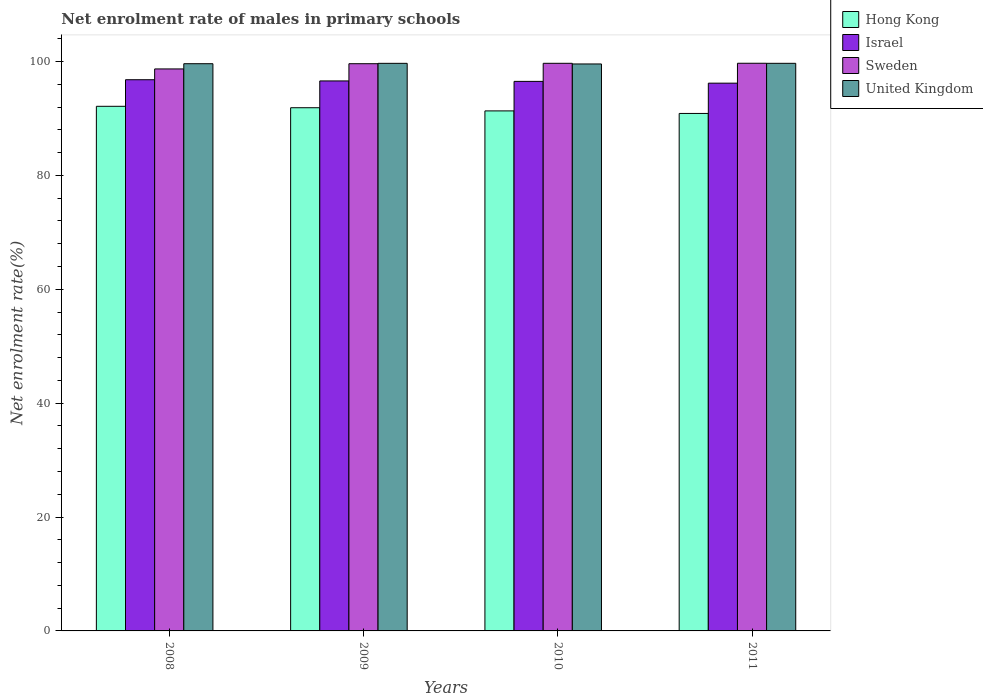Are the number of bars on each tick of the X-axis equal?
Your response must be concise. Yes. How many bars are there on the 1st tick from the left?
Provide a short and direct response. 4. How many bars are there on the 3rd tick from the right?
Provide a short and direct response. 4. In how many cases, is the number of bars for a given year not equal to the number of legend labels?
Ensure brevity in your answer.  0. What is the net enrolment rate of males in primary schools in Hong Kong in 2008?
Give a very brief answer. 92.14. Across all years, what is the maximum net enrolment rate of males in primary schools in Israel?
Offer a very short reply. 96.81. Across all years, what is the minimum net enrolment rate of males in primary schools in Sweden?
Give a very brief answer. 98.71. In which year was the net enrolment rate of males in primary schools in United Kingdom minimum?
Keep it short and to the point. 2010. What is the total net enrolment rate of males in primary schools in Hong Kong in the graph?
Ensure brevity in your answer.  366.26. What is the difference between the net enrolment rate of males in primary schools in Sweden in 2009 and that in 2010?
Ensure brevity in your answer.  -0.07. What is the difference between the net enrolment rate of males in primary schools in United Kingdom in 2011 and the net enrolment rate of males in primary schools in Sweden in 2009?
Offer a terse response. 0.07. What is the average net enrolment rate of males in primary schools in Hong Kong per year?
Your answer should be very brief. 91.57. In the year 2008, what is the difference between the net enrolment rate of males in primary schools in Hong Kong and net enrolment rate of males in primary schools in United Kingdom?
Ensure brevity in your answer.  -7.48. In how many years, is the net enrolment rate of males in primary schools in United Kingdom greater than 52 %?
Provide a succinct answer. 4. What is the ratio of the net enrolment rate of males in primary schools in Sweden in 2010 to that in 2011?
Offer a terse response. 1. What is the difference between the highest and the second highest net enrolment rate of males in primary schools in United Kingdom?
Give a very brief answer. 0. What is the difference between the highest and the lowest net enrolment rate of males in primary schools in Hong Kong?
Your response must be concise. 1.25. In how many years, is the net enrolment rate of males in primary schools in United Kingdom greater than the average net enrolment rate of males in primary schools in United Kingdom taken over all years?
Your response must be concise. 2. What does the 4th bar from the right in 2009 represents?
Your answer should be very brief. Hong Kong. How many bars are there?
Give a very brief answer. 16. What is the difference between two consecutive major ticks on the Y-axis?
Give a very brief answer. 20. Does the graph contain any zero values?
Your response must be concise. No. Where does the legend appear in the graph?
Your answer should be compact. Top right. How many legend labels are there?
Offer a terse response. 4. What is the title of the graph?
Give a very brief answer. Net enrolment rate of males in primary schools. Does "Europe(developing only)" appear as one of the legend labels in the graph?
Offer a very short reply. No. What is the label or title of the X-axis?
Your answer should be very brief. Years. What is the label or title of the Y-axis?
Your response must be concise. Net enrolment rate(%). What is the Net enrolment rate(%) in Hong Kong in 2008?
Provide a short and direct response. 92.14. What is the Net enrolment rate(%) in Israel in 2008?
Your answer should be very brief. 96.81. What is the Net enrolment rate(%) of Sweden in 2008?
Offer a very short reply. 98.71. What is the Net enrolment rate(%) in United Kingdom in 2008?
Provide a short and direct response. 99.63. What is the Net enrolment rate(%) of Hong Kong in 2009?
Offer a very short reply. 91.89. What is the Net enrolment rate(%) in Israel in 2009?
Your answer should be compact. 96.6. What is the Net enrolment rate(%) in Sweden in 2009?
Ensure brevity in your answer.  99.63. What is the Net enrolment rate(%) in United Kingdom in 2009?
Offer a terse response. 99.69. What is the Net enrolment rate(%) of Hong Kong in 2010?
Your response must be concise. 91.34. What is the Net enrolment rate(%) in Israel in 2010?
Provide a short and direct response. 96.52. What is the Net enrolment rate(%) in Sweden in 2010?
Your answer should be compact. 99.7. What is the Net enrolment rate(%) in United Kingdom in 2010?
Give a very brief answer. 99.58. What is the Net enrolment rate(%) of Hong Kong in 2011?
Offer a terse response. 90.89. What is the Net enrolment rate(%) of Israel in 2011?
Offer a terse response. 96.21. What is the Net enrolment rate(%) of Sweden in 2011?
Provide a short and direct response. 99.7. What is the Net enrolment rate(%) in United Kingdom in 2011?
Give a very brief answer. 99.69. Across all years, what is the maximum Net enrolment rate(%) of Hong Kong?
Provide a succinct answer. 92.14. Across all years, what is the maximum Net enrolment rate(%) in Israel?
Provide a succinct answer. 96.81. Across all years, what is the maximum Net enrolment rate(%) in Sweden?
Offer a very short reply. 99.7. Across all years, what is the maximum Net enrolment rate(%) of United Kingdom?
Your response must be concise. 99.69. Across all years, what is the minimum Net enrolment rate(%) in Hong Kong?
Give a very brief answer. 90.89. Across all years, what is the minimum Net enrolment rate(%) in Israel?
Provide a succinct answer. 96.21. Across all years, what is the minimum Net enrolment rate(%) of Sweden?
Provide a succinct answer. 98.71. Across all years, what is the minimum Net enrolment rate(%) in United Kingdom?
Ensure brevity in your answer.  99.58. What is the total Net enrolment rate(%) of Hong Kong in the graph?
Ensure brevity in your answer.  366.26. What is the total Net enrolment rate(%) of Israel in the graph?
Provide a short and direct response. 386.14. What is the total Net enrolment rate(%) in Sweden in the graph?
Give a very brief answer. 397.73. What is the total Net enrolment rate(%) in United Kingdom in the graph?
Offer a terse response. 398.59. What is the difference between the Net enrolment rate(%) in Hong Kong in 2008 and that in 2009?
Your answer should be compact. 0.25. What is the difference between the Net enrolment rate(%) in Israel in 2008 and that in 2009?
Your answer should be very brief. 0.21. What is the difference between the Net enrolment rate(%) of Sweden in 2008 and that in 2009?
Your answer should be compact. -0.92. What is the difference between the Net enrolment rate(%) in United Kingdom in 2008 and that in 2009?
Provide a short and direct response. -0.06. What is the difference between the Net enrolment rate(%) in Hong Kong in 2008 and that in 2010?
Offer a very short reply. 0.81. What is the difference between the Net enrolment rate(%) in Israel in 2008 and that in 2010?
Give a very brief answer. 0.29. What is the difference between the Net enrolment rate(%) of Sweden in 2008 and that in 2010?
Offer a terse response. -0.99. What is the difference between the Net enrolment rate(%) of United Kingdom in 2008 and that in 2010?
Keep it short and to the point. 0.04. What is the difference between the Net enrolment rate(%) of Hong Kong in 2008 and that in 2011?
Provide a succinct answer. 1.25. What is the difference between the Net enrolment rate(%) in Israel in 2008 and that in 2011?
Provide a succinct answer. 0.6. What is the difference between the Net enrolment rate(%) of Sweden in 2008 and that in 2011?
Your answer should be very brief. -1. What is the difference between the Net enrolment rate(%) of United Kingdom in 2008 and that in 2011?
Provide a succinct answer. -0.07. What is the difference between the Net enrolment rate(%) in Hong Kong in 2009 and that in 2010?
Your answer should be compact. 0.56. What is the difference between the Net enrolment rate(%) of Israel in 2009 and that in 2010?
Your response must be concise. 0.08. What is the difference between the Net enrolment rate(%) in Sweden in 2009 and that in 2010?
Ensure brevity in your answer.  -0.07. What is the difference between the Net enrolment rate(%) of United Kingdom in 2009 and that in 2010?
Make the answer very short. 0.11. What is the difference between the Net enrolment rate(%) in Hong Kong in 2009 and that in 2011?
Offer a terse response. 1. What is the difference between the Net enrolment rate(%) of Israel in 2009 and that in 2011?
Provide a short and direct response. 0.39. What is the difference between the Net enrolment rate(%) of Sweden in 2009 and that in 2011?
Keep it short and to the point. -0.08. What is the difference between the Net enrolment rate(%) in United Kingdom in 2009 and that in 2011?
Ensure brevity in your answer.  -0. What is the difference between the Net enrolment rate(%) in Hong Kong in 2010 and that in 2011?
Provide a succinct answer. 0.45. What is the difference between the Net enrolment rate(%) in Israel in 2010 and that in 2011?
Your answer should be very brief. 0.31. What is the difference between the Net enrolment rate(%) in Sweden in 2010 and that in 2011?
Your answer should be very brief. -0.01. What is the difference between the Net enrolment rate(%) of United Kingdom in 2010 and that in 2011?
Provide a short and direct response. -0.11. What is the difference between the Net enrolment rate(%) of Hong Kong in 2008 and the Net enrolment rate(%) of Israel in 2009?
Keep it short and to the point. -4.46. What is the difference between the Net enrolment rate(%) of Hong Kong in 2008 and the Net enrolment rate(%) of Sweden in 2009?
Your answer should be very brief. -7.48. What is the difference between the Net enrolment rate(%) in Hong Kong in 2008 and the Net enrolment rate(%) in United Kingdom in 2009?
Your response must be concise. -7.55. What is the difference between the Net enrolment rate(%) of Israel in 2008 and the Net enrolment rate(%) of Sweden in 2009?
Offer a very short reply. -2.81. What is the difference between the Net enrolment rate(%) in Israel in 2008 and the Net enrolment rate(%) in United Kingdom in 2009?
Make the answer very short. -2.88. What is the difference between the Net enrolment rate(%) in Sweden in 2008 and the Net enrolment rate(%) in United Kingdom in 2009?
Your answer should be compact. -0.98. What is the difference between the Net enrolment rate(%) in Hong Kong in 2008 and the Net enrolment rate(%) in Israel in 2010?
Give a very brief answer. -4.38. What is the difference between the Net enrolment rate(%) in Hong Kong in 2008 and the Net enrolment rate(%) in Sweden in 2010?
Your answer should be compact. -7.55. What is the difference between the Net enrolment rate(%) of Hong Kong in 2008 and the Net enrolment rate(%) of United Kingdom in 2010?
Your answer should be very brief. -7.44. What is the difference between the Net enrolment rate(%) in Israel in 2008 and the Net enrolment rate(%) in Sweden in 2010?
Your answer should be very brief. -2.89. What is the difference between the Net enrolment rate(%) of Israel in 2008 and the Net enrolment rate(%) of United Kingdom in 2010?
Provide a short and direct response. -2.77. What is the difference between the Net enrolment rate(%) of Sweden in 2008 and the Net enrolment rate(%) of United Kingdom in 2010?
Your response must be concise. -0.87. What is the difference between the Net enrolment rate(%) in Hong Kong in 2008 and the Net enrolment rate(%) in Israel in 2011?
Ensure brevity in your answer.  -4.06. What is the difference between the Net enrolment rate(%) in Hong Kong in 2008 and the Net enrolment rate(%) in Sweden in 2011?
Offer a very short reply. -7.56. What is the difference between the Net enrolment rate(%) in Hong Kong in 2008 and the Net enrolment rate(%) in United Kingdom in 2011?
Your response must be concise. -7.55. What is the difference between the Net enrolment rate(%) in Israel in 2008 and the Net enrolment rate(%) in Sweden in 2011?
Ensure brevity in your answer.  -2.89. What is the difference between the Net enrolment rate(%) in Israel in 2008 and the Net enrolment rate(%) in United Kingdom in 2011?
Your answer should be very brief. -2.88. What is the difference between the Net enrolment rate(%) in Sweden in 2008 and the Net enrolment rate(%) in United Kingdom in 2011?
Your response must be concise. -0.99. What is the difference between the Net enrolment rate(%) of Hong Kong in 2009 and the Net enrolment rate(%) of Israel in 2010?
Give a very brief answer. -4.63. What is the difference between the Net enrolment rate(%) in Hong Kong in 2009 and the Net enrolment rate(%) in Sweden in 2010?
Ensure brevity in your answer.  -7.8. What is the difference between the Net enrolment rate(%) in Hong Kong in 2009 and the Net enrolment rate(%) in United Kingdom in 2010?
Your answer should be compact. -7.69. What is the difference between the Net enrolment rate(%) in Israel in 2009 and the Net enrolment rate(%) in Sweden in 2010?
Ensure brevity in your answer.  -3.1. What is the difference between the Net enrolment rate(%) in Israel in 2009 and the Net enrolment rate(%) in United Kingdom in 2010?
Your response must be concise. -2.98. What is the difference between the Net enrolment rate(%) of Sweden in 2009 and the Net enrolment rate(%) of United Kingdom in 2010?
Ensure brevity in your answer.  0.04. What is the difference between the Net enrolment rate(%) of Hong Kong in 2009 and the Net enrolment rate(%) of Israel in 2011?
Keep it short and to the point. -4.31. What is the difference between the Net enrolment rate(%) in Hong Kong in 2009 and the Net enrolment rate(%) in Sweden in 2011?
Offer a very short reply. -7.81. What is the difference between the Net enrolment rate(%) of Hong Kong in 2009 and the Net enrolment rate(%) of United Kingdom in 2011?
Provide a succinct answer. -7.8. What is the difference between the Net enrolment rate(%) of Israel in 2009 and the Net enrolment rate(%) of Sweden in 2011?
Your response must be concise. -3.1. What is the difference between the Net enrolment rate(%) of Israel in 2009 and the Net enrolment rate(%) of United Kingdom in 2011?
Provide a short and direct response. -3.09. What is the difference between the Net enrolment rate(%) in Sweden in 2009 and the Net enrolment rate(%) in United Kingdom in 2011?
Provide a short and direct response. -0.07. What is the difference between the Net enrolment rate(%) of Hong Kong in 2010 and the Net enrolment rate(%) of Israel in 2011?
Your answer should be compact. -4.87. What is the difference between the Net enrolment rate(%) in Hong Kong in 2010 and the Net enrolment rate(%) in Sweden in 2011?
Provide a succinct answer. -8.37. What is the difference between the Net enrolment rate(%) of Hong Kong in 2010 and the Net enrolment rate(%) of United Kingdom in 2011?
Offer a very short reply. -8.36. What is the difference between the Net enrolment rate(%) in Israel in 2010 and the Net enrolment rate(%) in Sweden in 2011?
Your answer should be very brief. -3.18. What is the difference between the Net enrolment rate(%) in Israel in 2010 and the Net enrolment rate(%) in United Kingdom in 2011?
Ensure brevity in your answer.  -3.17. What is the difference between the Net enrolment rate(%) in Sweden in 2010 and the Net enrolment rate(%) in United Kingdom in 2011?
Provide a short and direct response. 0. What is the average Net enrolment rate(%) in Hong Kong per year?
Ensure brevity in your answer.  91.57. What is the average Net enrolment rate(%) of Israel per year?
Your response must be concise. 96.54. What is the average Net enrolment rate(%) of Sweden per year?
Provide a short and direct response. 99.43. What is the average Net enrolment rate(%) in United Kingdom per year?
Provide a succinct answer. 99.65. In the year 2008, what is the difference between the Net enrolment rate(%) of Hong Kong and Net enrolment rate(%) of Israel?
Your response must be concise. -4.67. In the year 2008, what is the difference between the Net enrolment rate(%) of Hong Kong and Net enrolment rate(%) of Sweden?
Offer a terse response. -6.56. In the year 2008, what is the difference between the Net enrolment rate(%) of Hong Kong and Net enrolment rate(%) of United Kingdom?
Offer a terse response. -7.48. In the year 2008, what is the difference between the Net enrolment rate(%) of Israel and Net enrolment rate(%) of Sweden?
Provide a succinct answer. -1.9. In the year 2008, what is the difference between the Net enrolment rate(%) in Israel and Net enrolment rate(%) in United Kingdom?
Your answer should be very brief. -2.81. In the year 2008, what is the difference between the Net enrolment rate(%) of Sweden and Net enrolment rate(%) of United Kingdom?
Offer a terse response. -0.92. In the year 2009, what is the difference between the Net enrolment rate(%) of Hong Kong and Net enrolment rate(%) of Israel?
Ensure brevity in your answer.  -4.71. In the year 2009, what is the difference between the Net enrolment rate(%) of Hong Kong and Net enrolment rate(%) of Sweden?
Provide a short and direct response. -7.73. In the year 2009, what is the difference between the Net enrolment rate(%) of Hong Kong and Net enrolment rate(%) of United Kingdom?
Offer a very short reply. -7.8. In the year 2009, what is the difference between the Net enrolment rate(%) of Israel and Net enrolment rate(%) of Sweden?
Your answer should be compact. -3.02. In the year 2009, what is the difference between the Net enrolment rate(%) in Israel and Net enrolment rate(%) in United Kingdom?
Offer a terse response. -3.09. In the year 2009, what is the difference between the Net enrolment rate(%) of Sweden and Net enrolment rate(%) of United Kingdom?
Give a very brief answer. -0.06. In the year 2010, what is the difference between the Net enrolment rate(%) of Hong Kong and Net enrolment rate(%) of Israel?
Your response must be concise. -5.19. In the year 2010, what is the difference between the Net enrolment rate(%) in Hong Kong and Net enrolment rate(%) in Sweden?
Provide a succinct answer. -8.36. In the year 2010, what is the difference between the Net enrolment rate(%) in Hong Kong and Net enrolment rate(%) in United Kingdom?
Make the answer very short. -8.24. In the year 2010, what is the difference between the Net enrolment rate(%) of Israel and Net enrolment rate(%) of Sweden?
Give a very brief answer. -3.17. In the year 2010, what is the difference between the Net enrolment rate(%) of Israel and Net enrolment rate(%) of United Kingdom?
Offer a very short reply. -3.06. In the year 2010, what is the difference between the Net enrolment rate(%) of Sweden and Net enrolment rate(%) of United Kingdom?
Ensure brevity in your answer.  0.12. In the year 2011, what is the difference between the Net enrolment rate(%) in Hong Kong and Net enrolment rate(%) in Israel?
Keep it short and to the point. -5.32. In the year 2011, what is the difference between the Net enrolment rate(%) in Hong Kong and Net enrolment rate(%) in Sweden?
Give a very brief answer. -8.81. In the year 2011, what is the difference between the Net enrolment rate(%) of Hong Kong and Net enrolment rate(%) of United Kingdom?
Your answer should be very brief. -8.8. In the year 2011, what is the difference between the Net enrolment rate(%) of Israel and Net enrolment rate(%) of Sweden?
Your answer should be compact. -3.5. In the year 2011, what is the difference between the Net enrolment rate(%) of Israel and Net enrolment rate(%) of United Kingdom?
Ensure brevity in your answer.  -3.49. In the year 2011, what is the difference between the Net enrolment rate(%) of Sweden and Net enrolment rate(%) of United Kingdom?
Ensure brevity in your answer.  0.01. What is the ratio of the Net enrolment rate(%) of Hong Kong in 2008 to that in 2009?
Provide a short and direct response. 1. What is the ratio of the Net enrolment rate(%) in United Kingdom in 2008 to that in 2009?
Ensure brevity in your answer.  1. What is the ratio of the Net enrolment rate(%) in Hong Kong in 2008 to that in 2010?
Make the answer very short. 1.01. What is the ratio of the Net enrolment rate(%) of Israel in 2008 to that in 2010?
Your answer should be compact. 1. What is the ratio of the Net enrolment rate(%) of United Kingdom in 2008 to that in 2010?
Your answer should be compact. 1. What is the ratio of the Net enrolment rate(%) in Hong Kong in 2008 to that in 2011?
Ensure brevity in your answer.  1.01. What is the ratio of the Net enrolment rate(%) of Sweden in 2008 to that in 2011?
Your answer should be compact. 0.99. What is the ratio of the Net enrolment rate(%) of Hong Kong in 2009 to that in 2010?
Provide a short and direct response. 1.01. What is the ratio of the Net enrolment rate(%) in Israel in 2009 to that in 2010?
Your answer should be very brief. 1. What is the ratio of the Net enrolment rate(%) in Israel in 2009 to that in 2011?
Your answer should be very brief. 1. What is the ratio of the Net enrolment rate(%) in Hong Kong in 2010 to that in 2011?
Keep it short and to the point. 1. What is the ratio of the Net enrolment rate(%) in Sweden in 2010 to that in 2011?
Ensure brevity in your answer.  1. What is the ratio of the Net enrolment rate(%) in United Kingdom in 2010 to that in 2011?
Offer a very short reply. 1. What is the difference between the highest and the second highest Net enrolment rate(%) in Hong Kong?
Your response must be concise. 0.25. What is the difference between the highest and the second highest Net enrolment rate(%) of Israel?
Your answer should be very brief. 0.21. What is the difference between the highest and the second highest Net enrolment rate(%) of Sweden?
Provide a succinct answer. 0.01. What is the difference between the highest and the second highest Net enrolment rate(%) of United Kingdom?
Your answer should be compact. 0. What is the difference between the highest and the lowest Net enrolment rate(%) in Hong Kong?
Your answer should be very brief. 1.25. What is the difference between the highest and the lowest Net enrolment rate(%) in Israel?
Offer a very short reply. 0.6. What is the difference between the highest and the lowest Net enrolment rate(%) in United Kingdom?
Your answer should be compact. 0.11. 